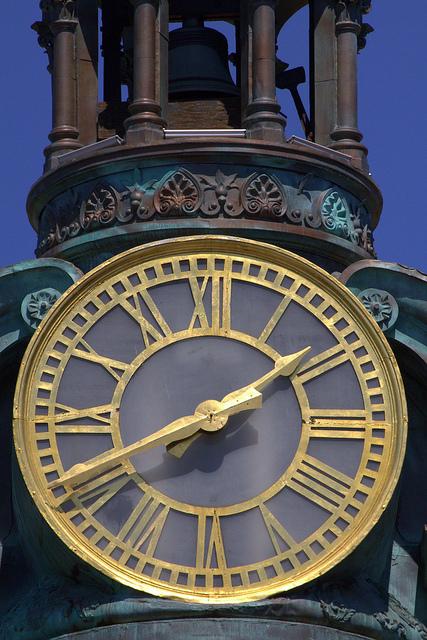What color is the clock?
Give a very brief answer. Black and gold. What time is it?
Quick response, please. 1:40. What is near the camera?
Write a very short answer. Clock. 